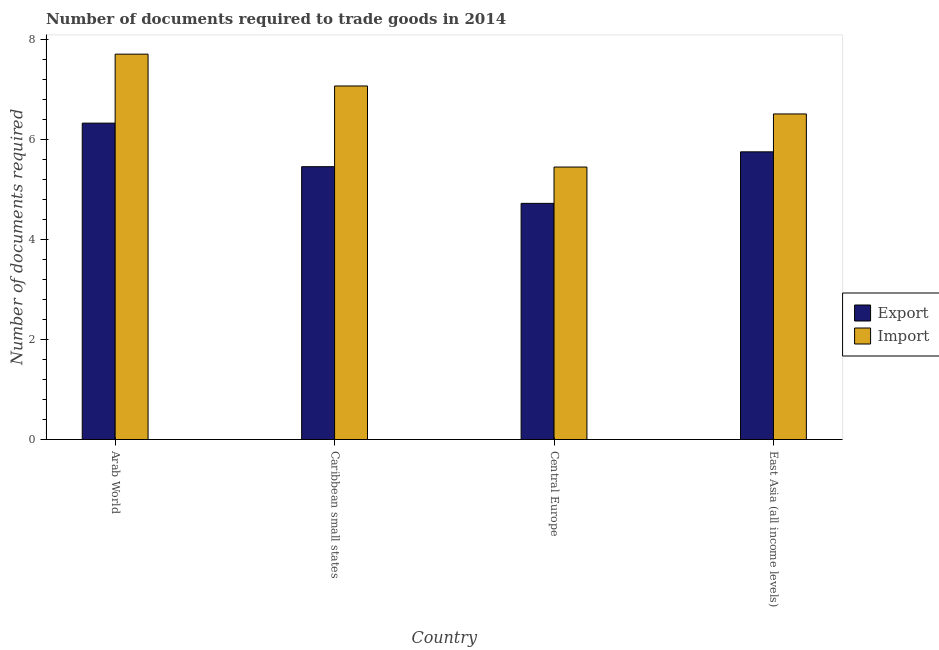How many groups of bars are there?
Keep it short and to the point. 4. What is the label of the 3rd group of bars from the left?
Your response must be concise. Central Europe. What is the number of documents required to export goods in Caribbean small states?
Offer a terse response. 5.46. Across all countries, what is the maximum number of documents required to export goods?
Your answer should be very brief. 6.33. Across all countries, what is the minimum number of documents required to export goods?
Make the answer very short. 4.73. In which country was the number of documents required to import goods maximum?
Offer a terse response. Arab World. In which country was the number of documents required to export goods minimum?
Provide a short and direct response. Central Europe. What is the total number of documents required to export goods in the graph?
Give a very brief answer. 22.28. What is the difference between the number of documents required to import goods in Caribbean small states and that in Central Europe?
Your response must be concise. 1.62. What is the difference between the number of documents required to export goods in Caribbean small states and the number of documents required to import goods in Central Europe?
Make the answer very short. 0.01. What is the average number of documents required to export goods per country?
Provide a short and direct response. 5.57. What is the difference between the number of documents required to export goods and number of documents required to import goods in Caribbean small states?
Make the answer very short. -1.62. In how many countries, is the number of documents required to export goods greater than 6.4 ?
Give a very brief answer. 0. What is the ratio of the number of documents required to import goods in Arab World to that in Central Europe?
Your answer should be compact. 1.41. What is the difference between the highest and the second highest number of documents required to export goods?
Offer a terse response. 0.57. What is the difference between the highest and the lowest number of documents required to export goods?
Your answer should be compact. 1.61. In how many countries, is the number of documents required to export goods greater than the average number of documents required to export goods taken over all countries?
Keep it short and to the point. 2. Is the sum of the number of documents required to export goods in Arab World and Central Europe greater than the maximum number of documents required to import goods across all countries?
Ensure brevity in your answer.  Yes. What does the 1st bar from the left in Arab World represents?
Offer a terse response. Export. What does the 2nd bar from the right in Caribbean small states represents?
Ensure brevity in your answer.  Export. Are all the bars in the graph horizontal?
Offer a very short reply. No. How many countries are there in the graph?
Offer a terse response. 4. Are the values on the major ticks of Y-axis written in scientific E-notation?
Ensure brevity in your answer.  No. Does the graph contain any zero values?
Give a very brief answer. No. Does the graph contain grids?
Your answer should be compact. No. Where does the legend appear in the graph?
Offer a terse response. Center right. How many legend labels are there?
Your answer should be very brief. 2. What is the title of the graph?
Your answer should be compact. Number of documents required to trade goods in 2014. What is the label or title of the Y-axis?
Your answer should be very brief. Number of documents required. What is the Number of documents required in Export in Arab World?
Give a very brief answer. 6.33. What is the Number of documents required in Import in Arab World?
Provide a short and direct response. 7.71. What is the Number of documents required of Export in Caribbean small states?
Offer a very short reply. 5.46. What is the Number of documents required of Import in Caribbean small states?
Your answer should be compact. 7.08. What is the Number of documents required in Export in Central Europe?
Provide a succinct answer. 4.73. What is the Number of documents required of Import in Central Europe?
Provide a short and direct response. 5.45. What is the Number of documents required in Export in East Asia (all income levels)?
Ensure brevity in your answer.  5.76. What is the Number of documents required of Import in East Asia (all income levels)?
Give a very brief answer. 6.52. Across all countries, what is the maximum Number of documents required of Export?
Give a very brief answer. 6.33. Across all countries, what is the maximum Number of documents required of Import?
Keep it short and to the point. 7.71. Across all countries, what is the minimum Number of documents required of Export?
Your answer should be compact. 4.73. Across all countries, what is the minimum Number of documents required in Import?
Give a very brief answer. 5.45. What is the total Number of documents required in Export in the graph?
Your answer should be very brief. 22.28. What is the total Number of documents required of Import in the graph?
Keep it short and to the point. 26.76. What is the difference between the Number of documents required of Export in Arab World and that in Caribbean small states?
Ensure brevity in your answer.  0.87. What is the difference between the Number of documents required of Import in Arab World and that in Caribbean small states?
Provide a succinct answer. 0.64. What is the difference between the Number of documents required in Export in Arab World and that in Central Europe?
Give a very brief answer. 1.61. What is the difference between the Number of documents required in Import in Arab World and that in Central Europe?
Provide a succinct answer. 2.26. What is the difference between the Number of documents required in Export in Arab World and that in East Asia (all income levels)?
Keep it short and to the point. 0.57. What is the difference between the Number of documents required in Import in Arab World and that in East Asia (all income levels)?
Offer a terse response. 1.2. What is the difference between the Number of documents required of Export in Caribbean small states and that in Central Europe?
Offer a terse response. 0.73. What is the difference between the Number of documents required of Import in Caribbean small states and that in Central Europe?
Keep it short and to the point. 1.62. What is the difference between the Number of documents required in Export in Caribbean small states and that in East Asia (all income levels)?
Your answer should be very brief. -0.3. What is the difference between the Number of documents required in Import in Caribbean small states and that in East Asia (all income levels)?
Provide a succinct answer. 0.56. What is the difference between the Number of documents required in Export in Central Europe and that in East Asia (all income levels)?
Offer a terse response. -1.03. What is the difference between the Number of documents required of Import in Central Europe and that in East Asia (all income levels)?
Your answer should be compact. -1.06. What is the difference between the Number of documents required of Export in Arab World and the Number of documents required of Import in Caribbean small states?
Offer a terse response. -0.74. What is the difference between the Number of documents required in Export in Arab World and the Number of documents required in Import in Central Europe?
Your answer should be very brief. 0.88. What is the difference between the Number of documents required of Export in Arab World and the Number of documents required of Import in East Asia (all income levels)?
Keep it short and to the point. -0.18. What is the difference between the Number of documents required in Export in Caribbean small states and the Number of documents required in Import in Central Europe?
Provide a short and direct response. 0.01. What is the difference between the Number of documents required in Export in Caribbean small states and the Number of documents required in Import in East Asia (all income levels)?
Your answer should be compact. -1.06. What is the difference between the Number of documents required in Export in Central Europe and the Number of documents required in Import in East Asia (all income levels)?
Your response must be concise. -1.79. What is the average Number of documents required in Export per country?
Provide a succinct answer. 5.57. What is the average Number of documents required in Import per country?
Give a very brief answer. 6.69. What is the difference between the Number of documents required in Export and Number of documents required in Import in Arab World?
Make the answer very short. -1.38. What is the difference between the Number of documents required of Export and Number of documents required of Import in Caribbean small states?
Offer a terse response. -1.62. What is the difference between the Number of documents required of Export and Number of documents required of Import in Central Europe?
Provide a short and direct response. -0.73. What is the difference between the Number of documents required in Export and Number of documents required in Import in East Asia (all income levels)?
Keep it short and to the point. -0.76. What is the ratio of the Number of documents required in Export in Arab World to that in Caribbean small states?
Provide a succinct answer. 1.16. What is the ratio of the Number of documents required in Import in Arab World to that in Caribbean small states?
Offer a terse response. 1.09. What is the ratio of the Number of documents required in Export in Arab World to that in Central Europe?
Provide a succinct answer. 1.34. What is the ratio of the Number of documents required in Import in Arab World to that in Central Europe?
Your response must be concise. 1.41. What is the ratio of the Number of documents required of Export in Arab World to that in East Asia (all income levels)?
Offer a terse response. 1.1. What is the ratio of the Number of documents required of Import in Arab World to that in East Asia (all income levels)?
Your response must be concise. 1.18. What is the ratio of the Number of documents required in Export in Caribbean small states to that in Central Europe?
Offer a very short reply. 1.16. What is the ratio of the Number of documents required of Import in Caribbean small states to that in Central Europe?
Provide a succinct answer. 1.3. What is the ratio of the Number of documents required in Export in Caribbean small states to that in East Asia (all income levels)?
Offer a terse response. 0.95. What is the ratio of the Number of documents required in Import in Caribbean small states to that in East Asia (all income levels)?
Make the answer very short. 1.09. What is the ratio of the Number of documents required in Export in Central Europe to that in East Asia (all income levels)?
Your response must be concise. 0.82. What is the ratio of the Number of documents required in Import in Central Europe to that in East Asia (all income levels)?
Your response must be concise. 0.84. What is the difference between the highest and the second highest Number of documents required of Export?
Offer a terse response. 0.57. What is the difference between the highest and the second highest Number of documents required of Import?
Make the answer very short. 0.64. What is the difference between the highest and the lowest Number of documents required in Export?
Provide a succinct answer. 1.61. What is the difference between the highest and the lowest Number of documents required of Import?
Offer a terse response. 2.26. 